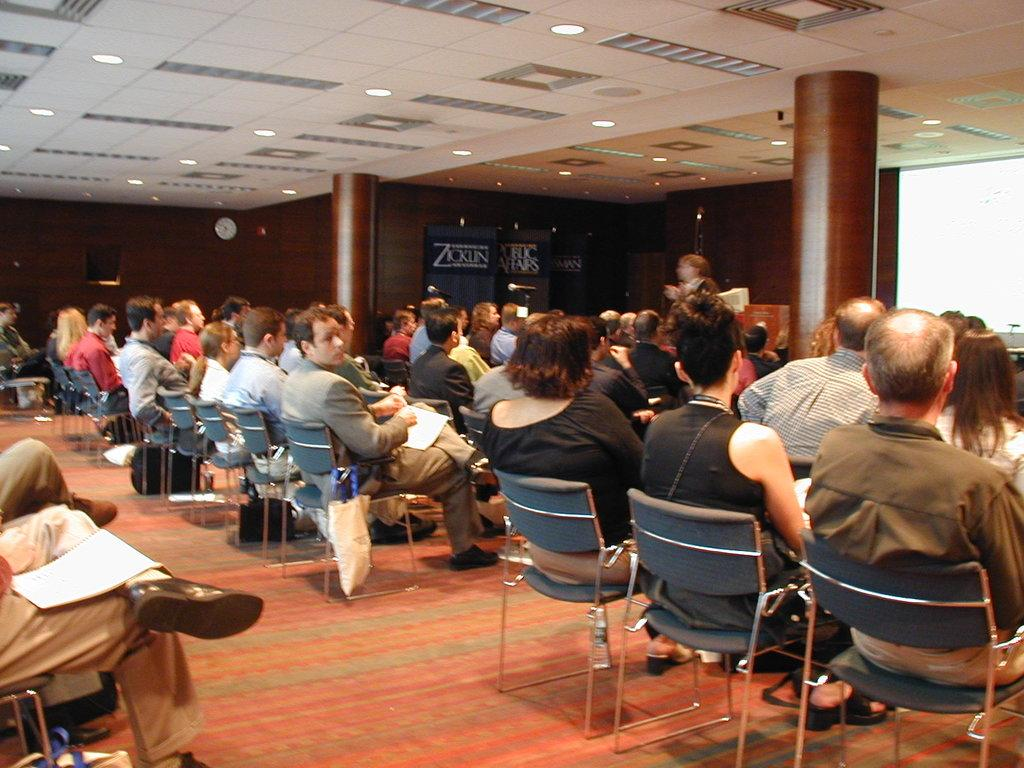What are the people in the image doing? The people in the image are sitting on chairs. What can be seen in the background of the image? In the background of the image, there is a projector screen, pillars, a wall clock, and banners. Can you describe the setting of the image? The setting of the image appears to be a room with chairs, a projector screen, pillars, a wall clock, and banners. What type of garden can be seen in the image? There is no garden present in the image; it features people sitting on chairs in a room with a projector screen, pillars, a wall clock, and banners. What story is being told on the projector screen in the image? There is no story being told on the projector screen in the image; it is just a screen visible in the background. 